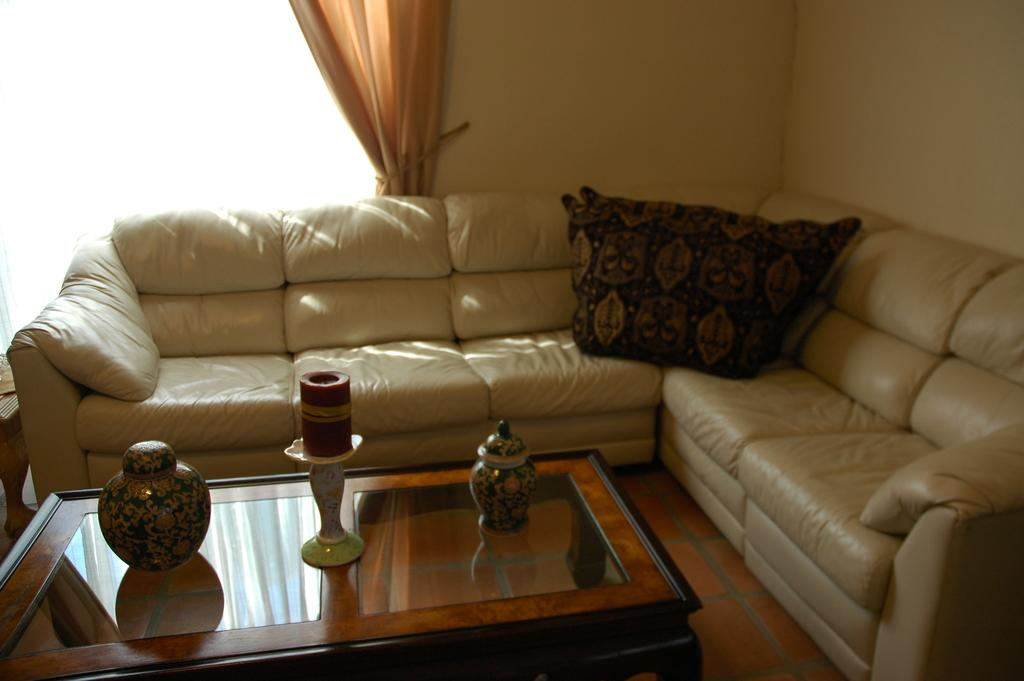What color is the sofa in the living room? The sofa in the living room is cream color. What can be found on the sofa? The sofa has dark color pillows on it. What is located beside the sofa? There is a table beside the sofa. What is on the table? There are items on the table. What feature allows natural light into the living room? There is a glass window in the living room. What is used to cover the glass window? There is a curtain beside the glass window. What type of card is being used to hold the curtain in place? There is no card present in the image; the curtain is not being held in place by a card. 